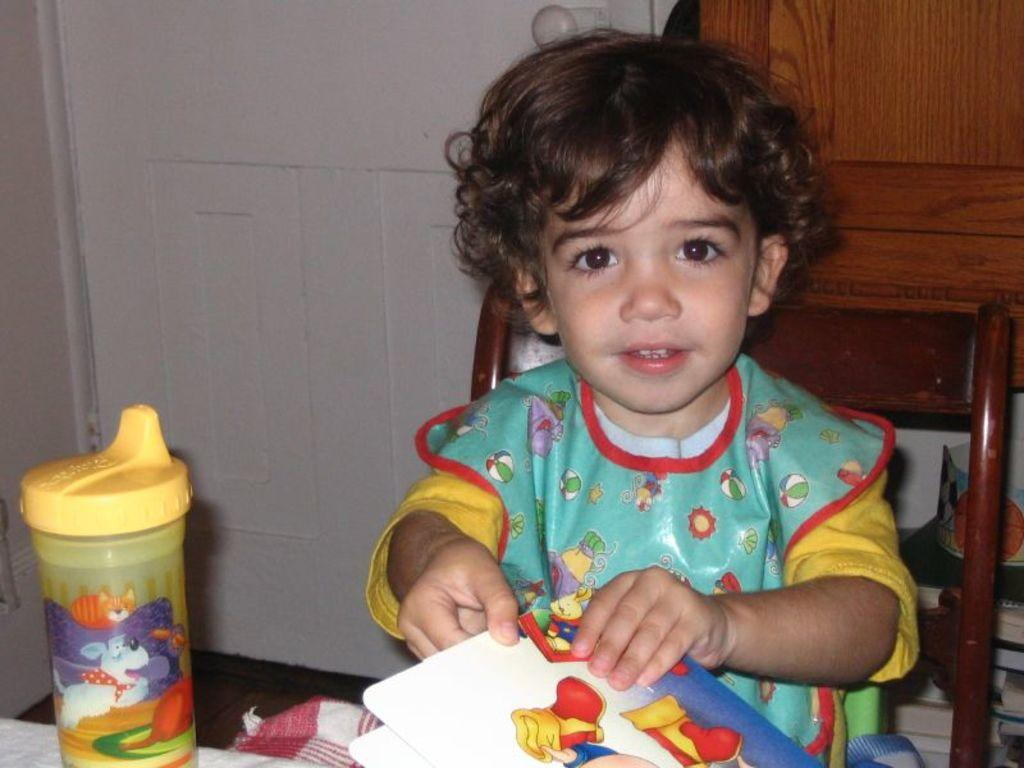Who is the main subject in the image? There is a girl in the image. What is the girl doing in the image? The girl is sitting in a chair and playing with a book in her hand. What type of throat-soothing remedy is the girl drinking in the image? There is no throat-soothing remedy or any drink present in the image; the girl is playing with a book. 